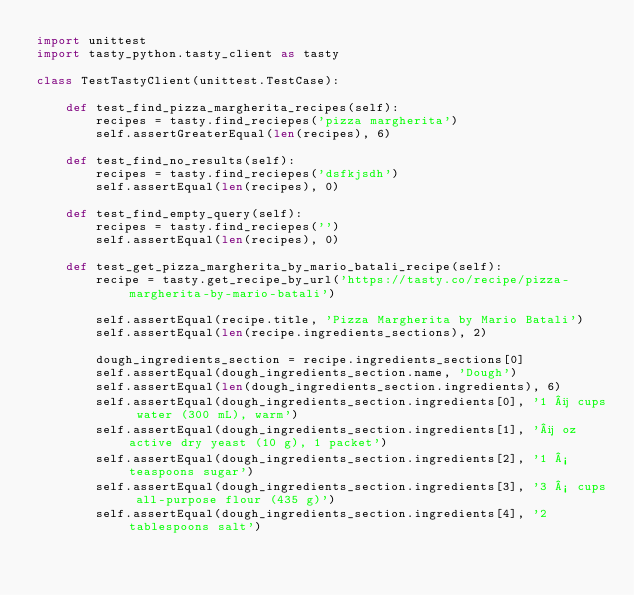Convert code to text. <code><loc_0><loc_0><loc_500><loc_500><_Python_>import unittest
import tasty_python.tasty_client as tasty

class TestTastyClient(unittest.TestCase):

    def test_find_pizza_margherita_recipes(self):
        recipes = tasty.find_reciepes('pizza margherita')
        self.assertGreaterEqual(len(recipes), 6)

    def test_find_no_results(self):
        recipes = tasty.find_reciepes('dsfkjsdh')
        self.assertEqual(len(recipes), 0)

    def test_find_empty_query(self):
        recipes = tasty.find_reciepes('')
        self.assertEqual(len(recipes), 0)

    def test_get_pizza_margherita_by_mario_batali_recipe(self):
        recipe = tasty.get_recipe_by_url('https://tasty.co/recipe/pizza-margherita-by-mario-batali')

        self.assertEqual(recipe.title, 'Pizza Margherita by Mario Batali')
        self.assertEqual(len(recipe.ingredients_sections), 2)

        dough_ingredients_section = recipe.ingredients_sections[0]
        self.assertEqual(dough_ingredients_section.name, 'Dough')
        self.assertEqual(len(dough_ingredients_section.ingredients), 6)
        self.assertEqual(dough_ingredients_section.ingredients[0], '1 ¼ cups water (300 mL), warm')
        self.assertEqual(dough_ingredients_section.ingredients[1], '¼ oz active dry yeast (10 g), 1 packet')
        self.assertEqual(dough_ingredients_section.ingredients[2], '1 ½ teaspoons sugar')
        self.assertEqual(dough_ingredients_section.ingredients[3], '3 ½ cups all-purpose flour (435 g)')
        self.assertEqual(dough_ingredients_section.ingredients[4], '2 tablespoons salt')</code> 